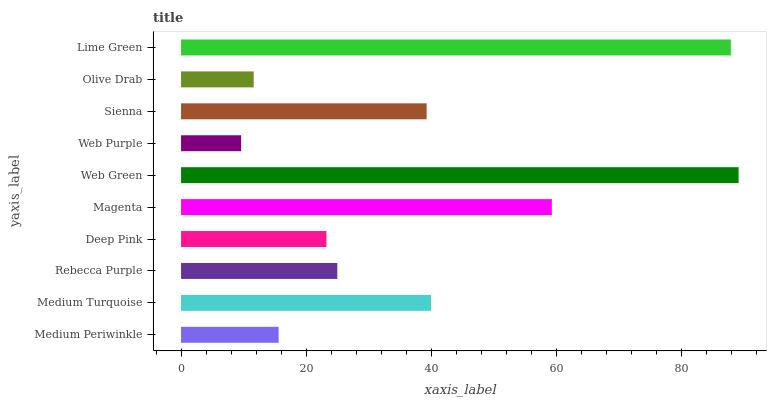Is Web Purple the minimum?
Answer yes or no. Yes. Is Web Green the maximum?
Answer yes or no. Yes. Is Medium Turquoise the minimum?
Answer yes or no. No. Is Medium Turquoise the maximum?
Answer yes or no. No. Is Medium Turquoise greater than Medium Periwinkle?
Answer yes or no. Yes. Is Medium Periwinkle less than Medium Turquoise?
Answer yes or no. Yes. Is Medium Periwinkle greater than Medium Turquoise?
Answer yes or no. No. Is Medium Turquoise less than Medium Periwinkle?
Answer yes or no. No. Is Sienna the high median?
Answer yes or no. Yes. Is Rebecca Purple the low median?
Answer yes or no. Yes. Is Medium Periwinkle the high median?
Answer yes or no. No. Is Olive Drab the low median?
Answer yes or no. No. 